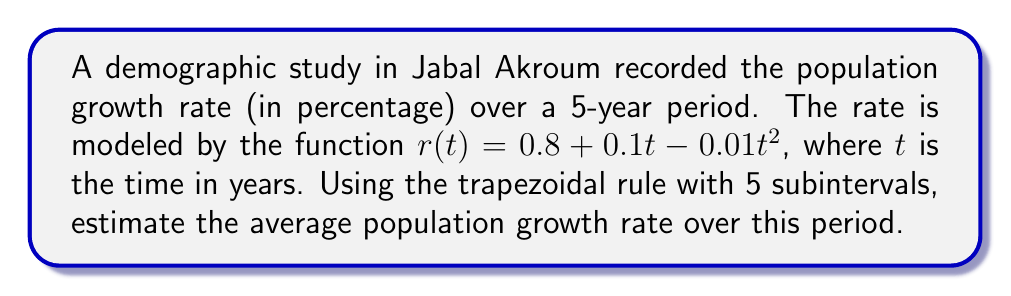Help me with this question. To estimate the average population growth rate, we need to calculate the definite integral of $r(t)$ from 0 to 5 and divide by the total time period.

1) The trapezoidal rule for $n$ subintervals is given by:

   $$\int_{a}^{b} f(x) dx \approx \frac{h}{2} [f(x_0) + 2f(x_1) + 2f(x_2) + ... + 2f(x_{n-1}) + f(x_n)]$$

   where $h = \frac{b-a}{n}$

2) In our case, $a=0$, $b=5$, and $n=5$. So, $h = \frac{5-0}{5} = 1$

3) Calculate $r(t)$ for $t = 0, 1, 2, 3, 4, 5$:

   $r(0) = 0.8 + 0.1(0) - 0.01(0)^2 = 0.8$
   $r(1) = 0.8 + 0.1(1) - 0.01(1)^2 = 0.89$
   $r(2) = 0.8 + 0.1(2) - 0.01(2)^2 = 0.96$
   $r(3) = 0.8 + 0.1(3) - 0.01(3)^2 = 1.01$
   $r(4) = 0.8 + 0.1(4) - 0.01(4)^2 = 1.04$
   $r(5) = 0.8 + 0.1(5) - 0.01(5)^2 = 1.05$

4) Apply the trapezoidal rule:

   $$\int_{0}^{5} r(t) dt \approx \frac{1}{2} [0.8 + 2(0.89) + 2(0.96) + 2(1.01) + 2(1.04) + 1.05]$$
   $$= \frac{1}{2} [0.8 + 1.78 + 1.92 + 2.02 + 2.08 + 1.05]$$
   $$= \frac{1}{2} (9.65) = 4.825$$

5) Calculate the average by dividing by the time period:

   Average rate = $\frac{4.825}{5} = 0.965$

Therefore, the estimated average population growth rate is 0.965% per year.
Answer: 0.965% 